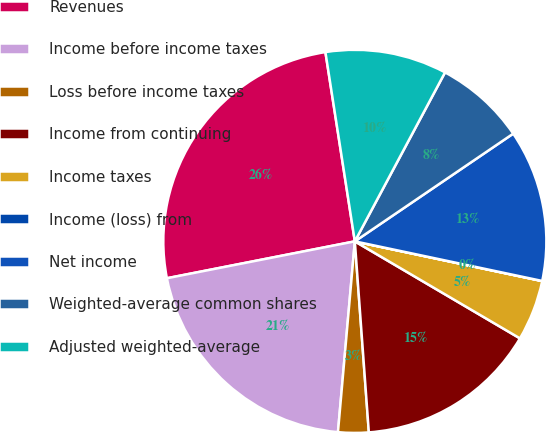Convert chart to OTSL. <chart><loc_0><loc_0><loc_500><loc_500><pie_chart><fcel>Revenues<fcel>Income before income taxes<fcel>Loss before income taxes<fcel>Income from continuing<fcel>Income taxes<fcel>Income (loss) from<fcel>Net income<fcel>Weighted-average common shares<fcel>Adjusted weighted-average<nl><fcel>25.63%<fcel>20.51%<fcel>2.57%<fcel>15.38%<fcel>5.13%<fcel>0.01%<fcel>12.82%<fcel>7.69%<fcel>10.26%<nl></chart> 